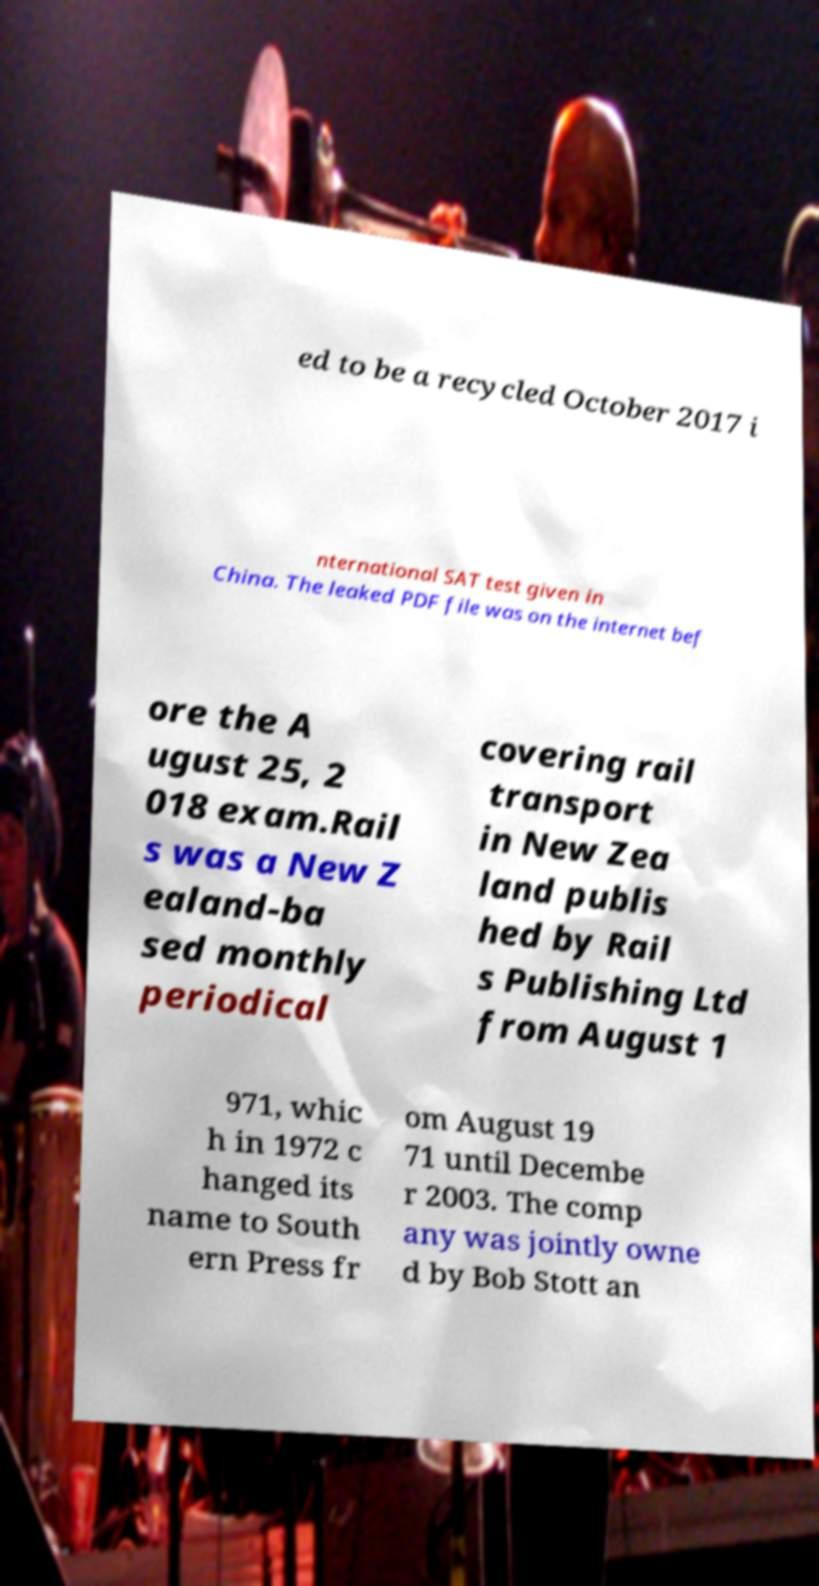Could you extract and type out the text from this image? ed to be a recycled October 2017 i nternational SAT test given in China. The leaked PDF file was on the internet bef ore the A ugust 25, 2 018 exam.Rail s was a New Z ealand-ba sed monthly periodical covering rail transport in New Zea land publis hed by Rail s Publishing Ltd from August 1 971, whic h in 1972 c hanged its name to South ern Press fr om August 19 71 until Decembe r 2003. The comp any was jointly owne d by Bob Stott an 